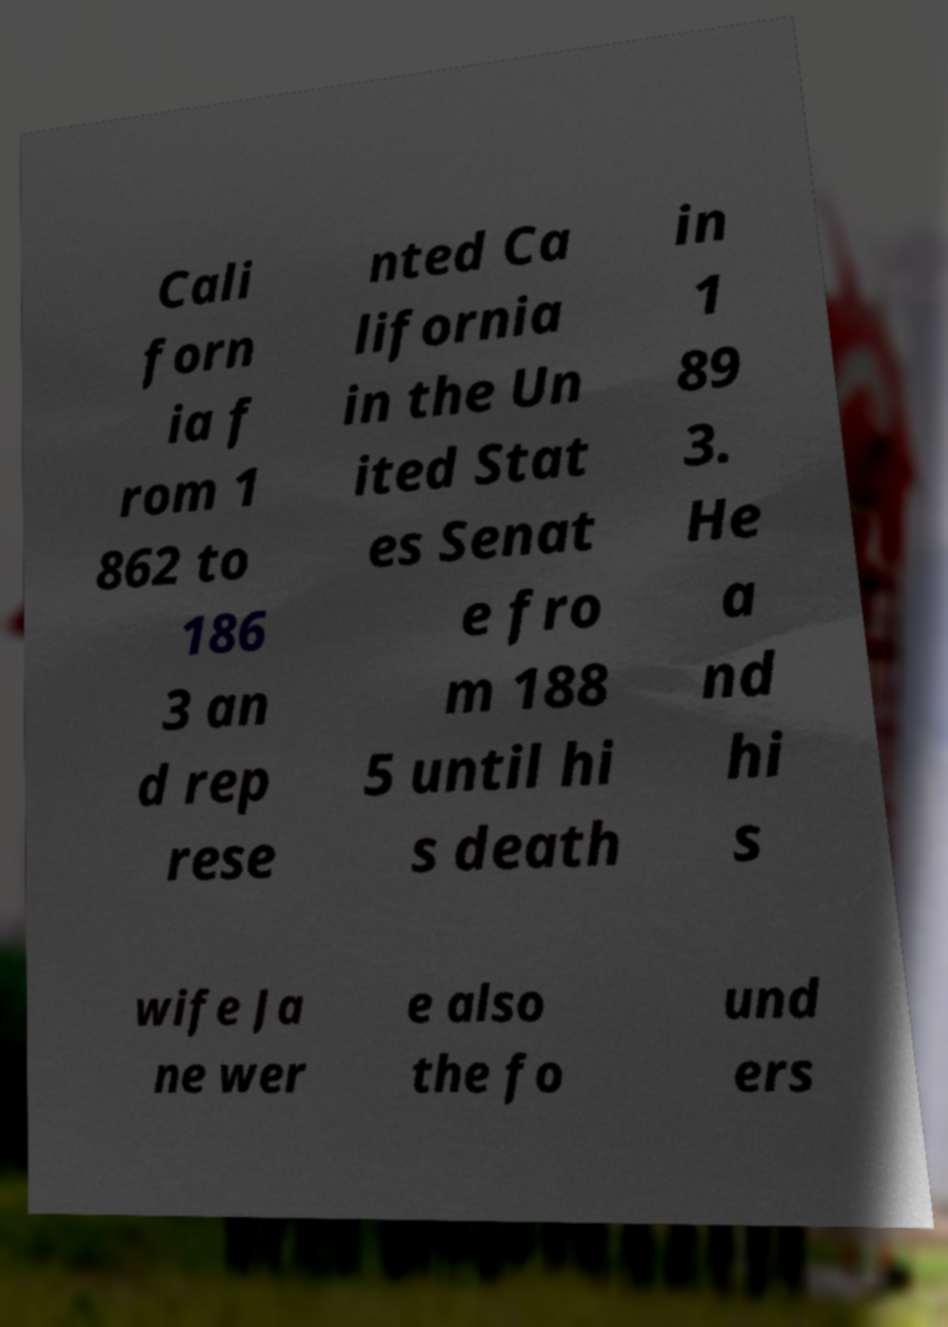For documentation purposes, I need the text within this image transcribed. Could you provide that? Cali forn ia f rom 1 862 to 186 3 an d rep rese nted Ca lifornia in the Un ited Stat es Senat e fro m 188 5 until hi s death in 1 89 3. He a nd hi s wife Ja ne wer e also the fo und ers 